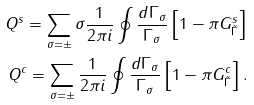Convert formula to latex. <formula><loc_0><loc_0><loc_500><loc_500>Q ^ { s } = \sum _ { \sigma = \pm } \sigma \frac { 1 } { 2 \pi i } \oint \frac { d \Gamma _ { \sigma } } { \Gamma _ { \sigma } } \left [ 1 - \pi G ^ { s } _ { \tilde { \Gamma } } \right ] \\ Q ^ { c } = \sum _ { \sigma = \pm } \frac { 1 } { 2 \pi i } \oint \frac { d \Gamma _ { \sigma } } { \Gamma _ { \sigma } } \left [ 1 - \pi G ^ { c } _ { \tilde { \Gamma } } \right ] .</formula> 